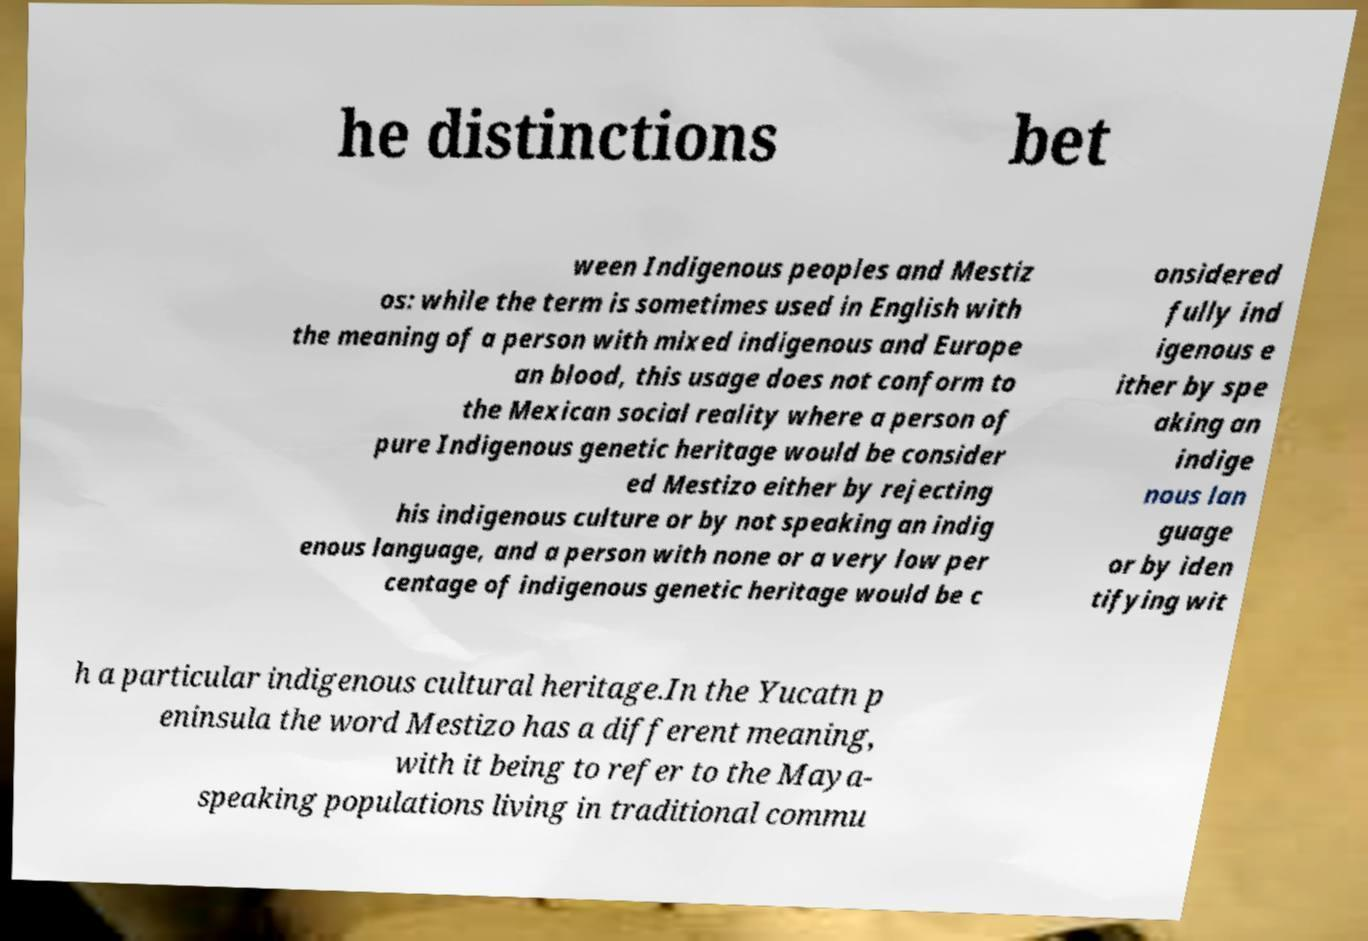Can you read and provide the text displayed in the image?This photo seems to have some interesting text. Can you extract and type it out for me? he distinctions bet ween Indigenous peoples and Mestiz os: while the term is sometimes used in English with the meaning of a person with mixed indigenous and Europe an blood, this usage does not conform to the Mexican social reality where a person of pure Indigenous genetic heritage would be consider ed Mestizo either by rejecting his indigenous culture or by not speaking an indig enous language, and a person with none or a very low per centage of indigenous genetic heritage would be c onsidered fully ind igenous e ither by spe aking an indige nous lan guage or by iden tifying wit h a particular indigenous cultural heritage.In the Yucatn p eninsula the word Mestizo has a different meaning, with it being to refer to the Maya- speaking populations living in traditional commu 